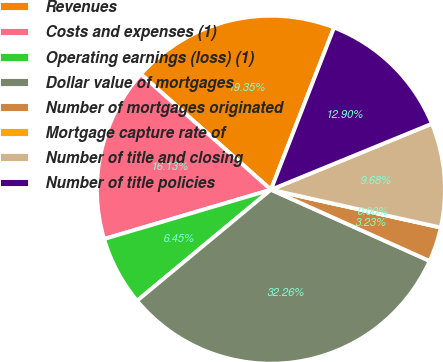Convert chart to OTSL. <chart><loc_0><loc_0><loc_500><loc_500><pie_chart><fcel>Revenues<fcel>Costs and expenses (1)<fcel>Operating earnings (loss) (1)<fcel>Dollar value of mortgages<fcel>Number of mortgages originated<fcel>Mortgage capture rate of<fcel>Number of title and closing<fcel>Number of title policies<nl><fcel>19.35%<fcel>16.13%<fcel>6.45%<fcel>32.26%<fcel>3.23%<fcel>0.0%<fcel>9.68%<fcel>12.9%<nl></chart> 